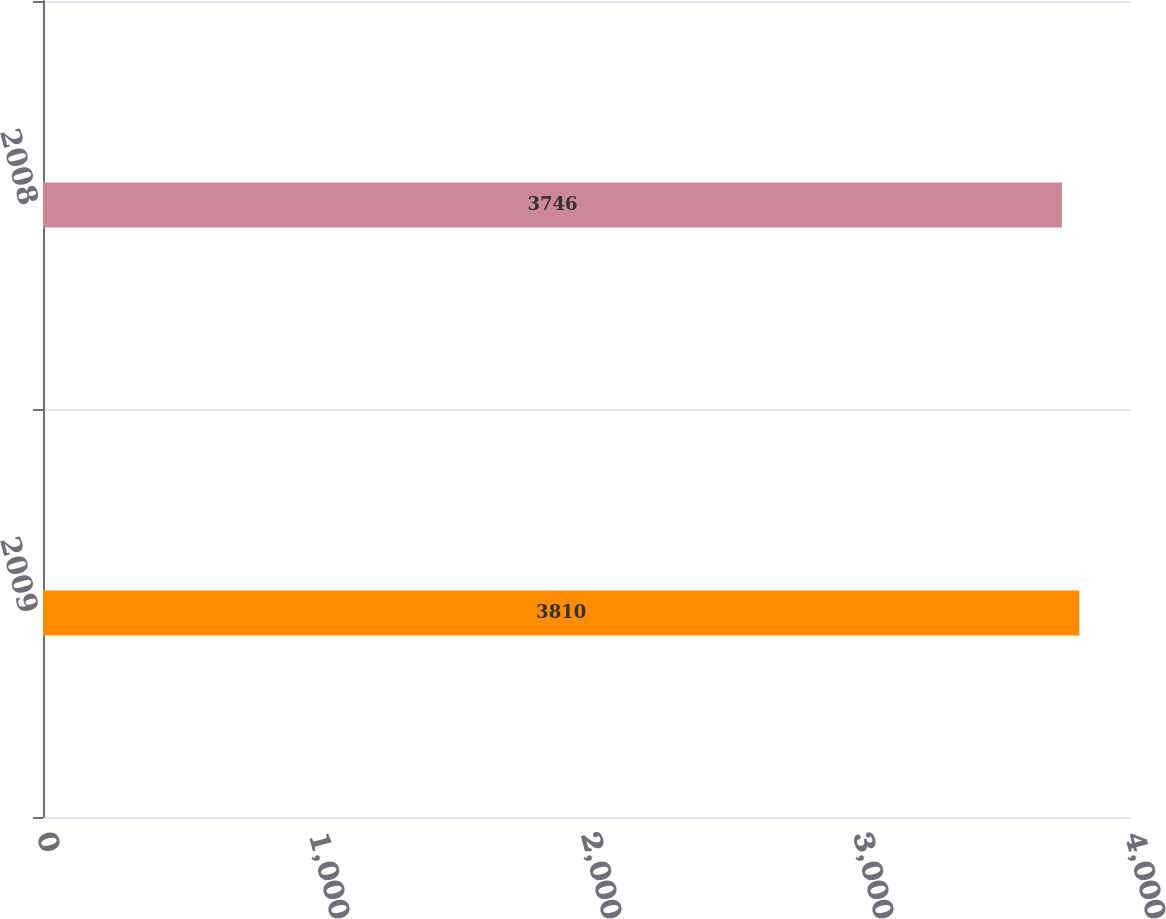<chart> <loc_0><loc_0><loc_500><loc_500><bar_chart><fcel>2009<fcel>2008<nl><fcel>3810<fcel>3746<nl></chart> 